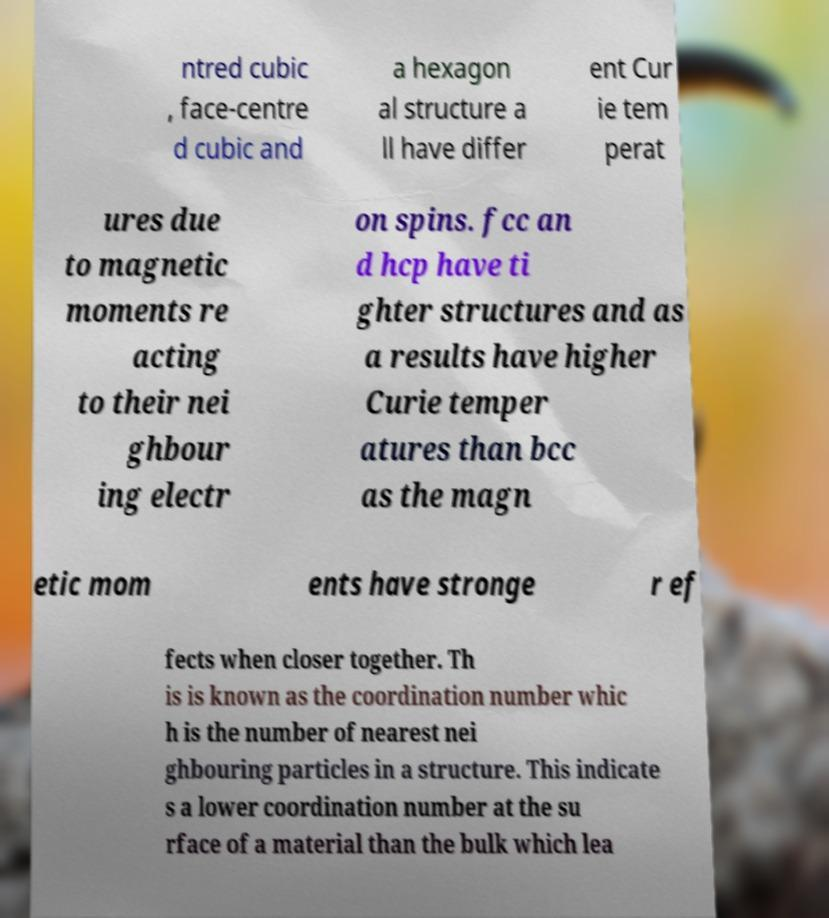Can you read and provide the text displayed in the image?This photo seems to have some interesting text. Can you extract and type it out for me? ntred cubic , face-centre d cubic and a hexagon al structure a ll have differ ent Cur ie tem perat ures due to magnetic moments re acting to their nei ghbour ing electr on spins. fcc an d hcp have ti ghter structures and as a results have higher Curie temper atures than bcc as the magn etic mom ents have stronge r ef fects when closer together. Th is is known as the coordination number whic h is the number of nearest nei ghbouring particles in a structure. This indicate s a lower coordination number at the su rface of a material than the bulk which lea 